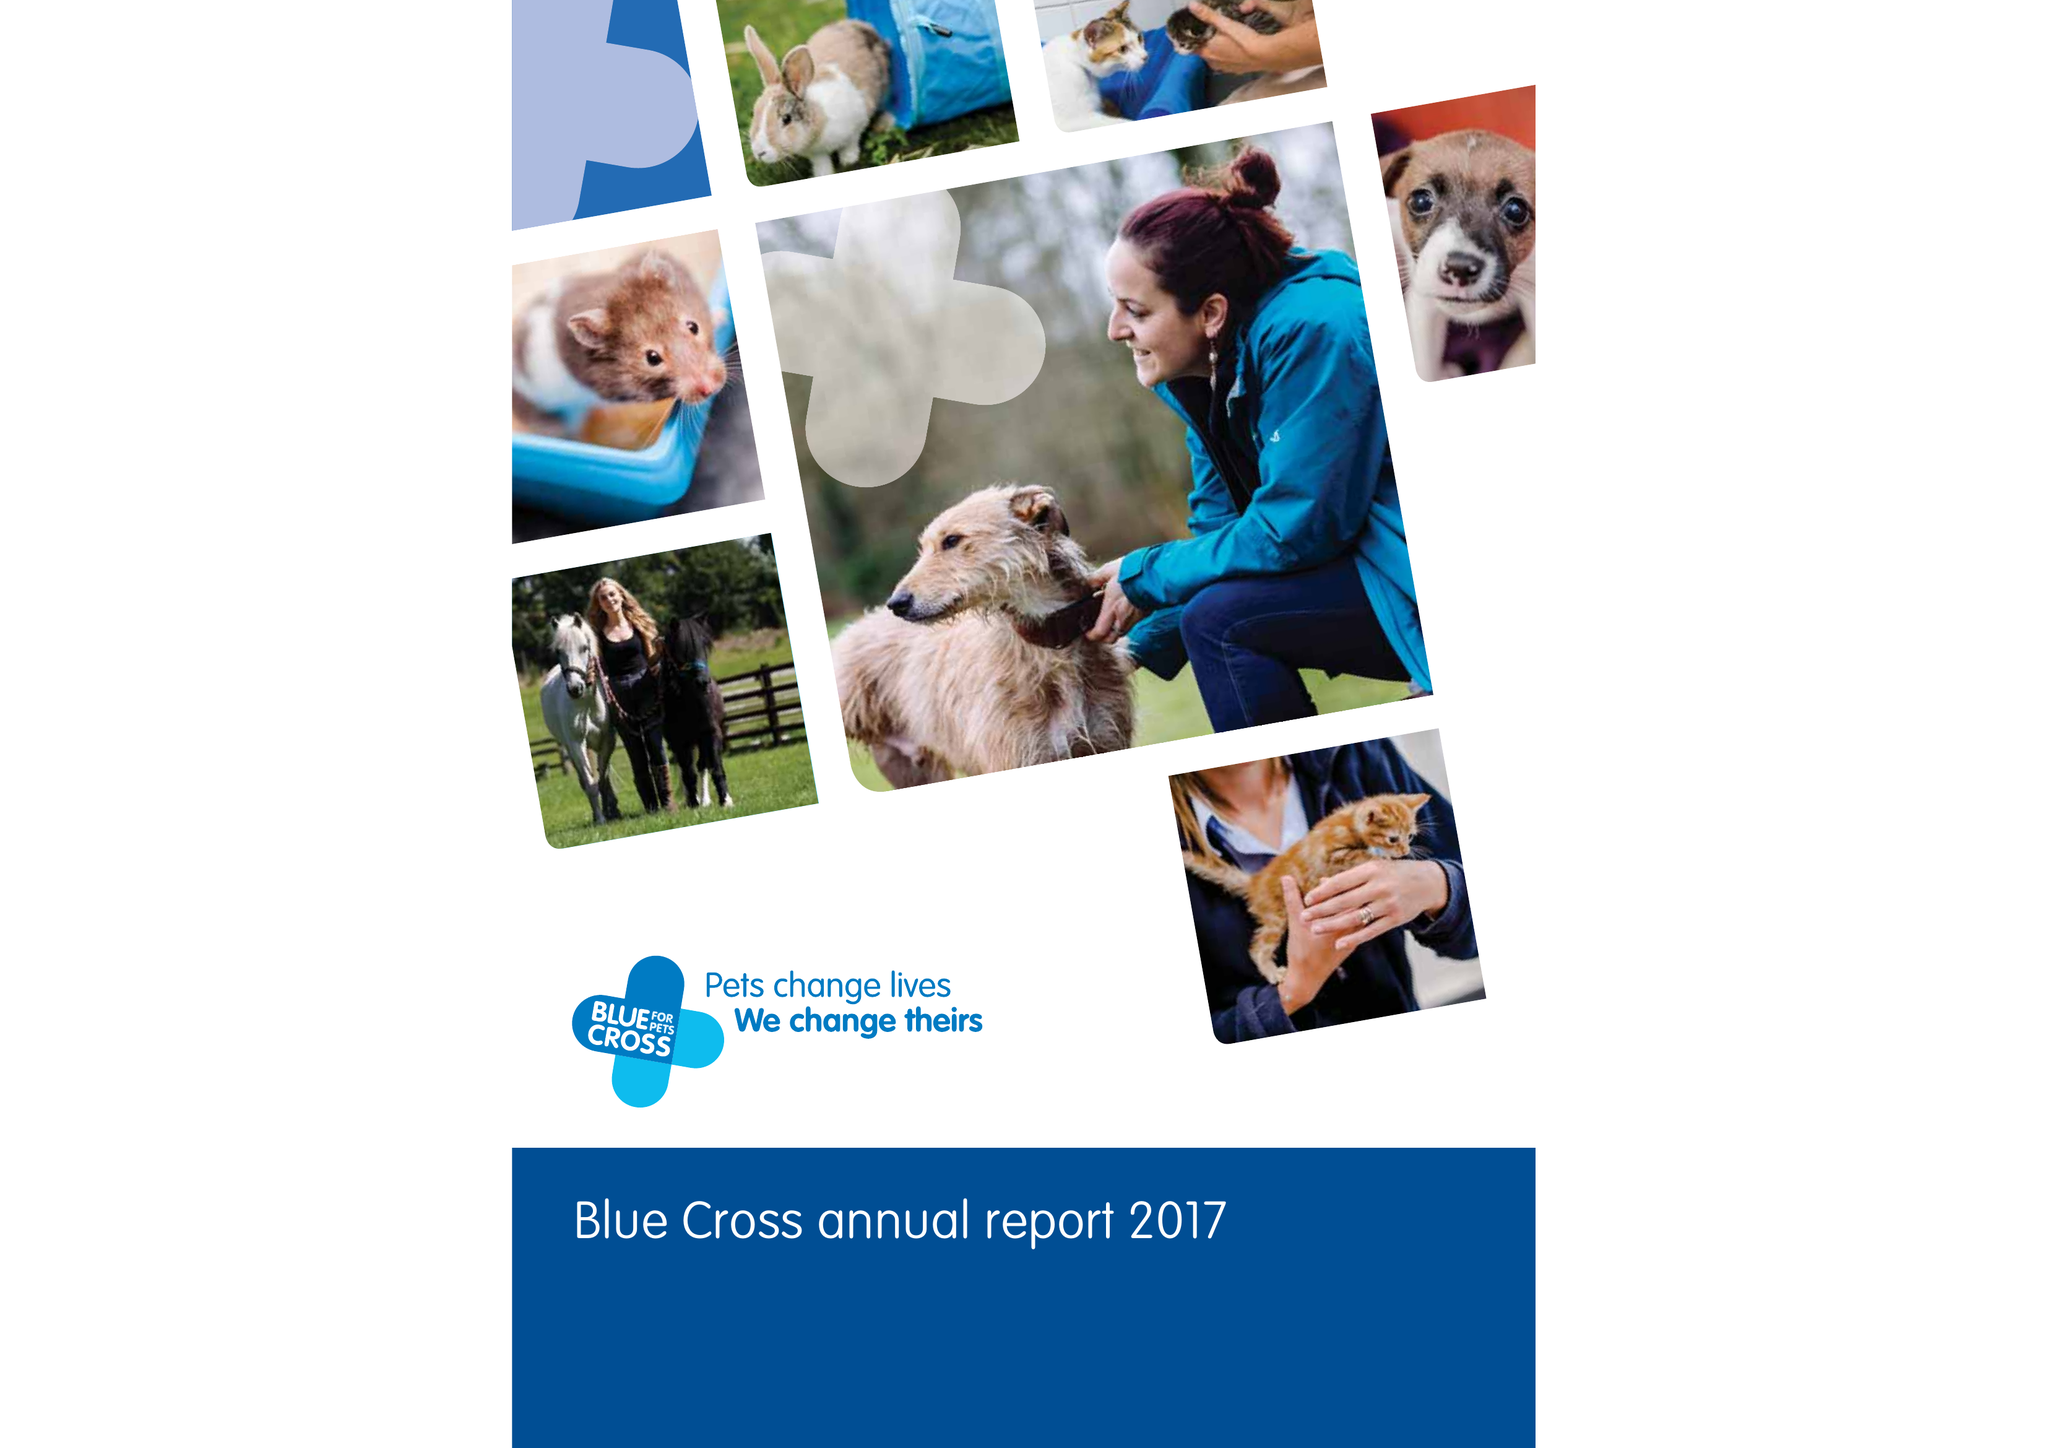What is the value for the charity_name?
Answer the question using a single word or phrase. Blue Cross 